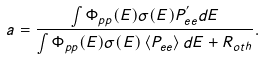<formula> <loc_0><loc_0><loc_500><loc_500>a = \frac { \int \Phi _ { p p } ( E ) \sigma ( E ) P _ { e e } ^ { ^ { \prime } } d E } { \int \Phi _ { p p } ( E ) \sigma ( E ) \left < P _ { e e } \right > d E + R _ { o t h } } .</formula> 